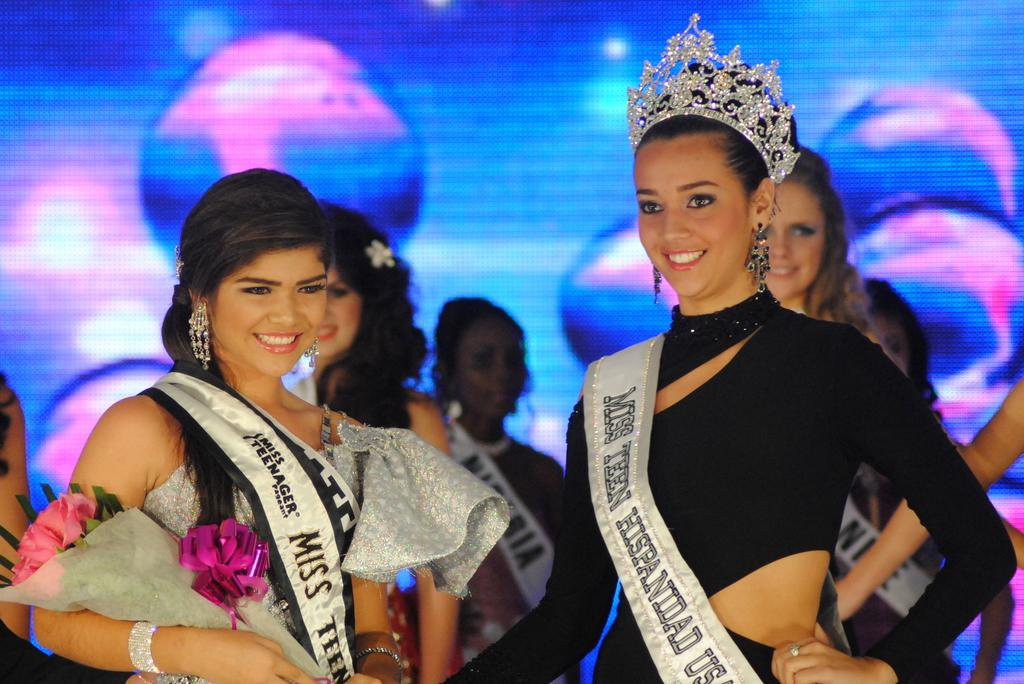<image>
Create a compact narrative representing the image presented. a lady with the word Miss on her tag 